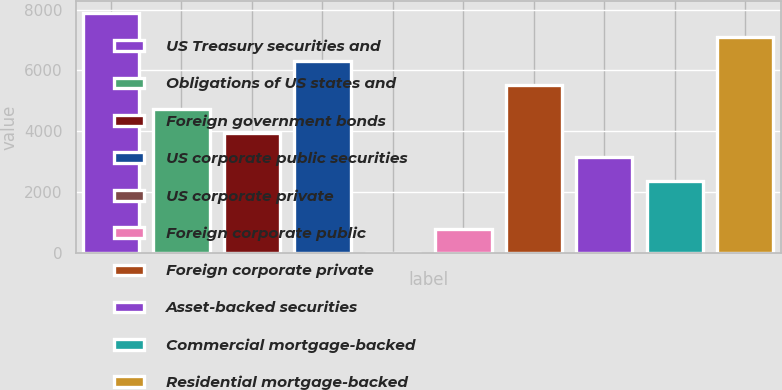Convert chart to OTSL. <chart><loc_0><loc_0><loc_500><loc_500><bar_chart><fcel>US Treasury securities and<fcel>Obligations of US states and<fcel>Foreign government bonds<fcel>US corporate public securities<fcel>US corporate private<fcel>Foreign corporate public<fcel>Foreign corporate private<fcel>Asset-backed securities<fcel>Commercial mortgage-backed<fcel>Residential mortgage-backed<nl><fcel>7881.96<fcel>4729.28<fcel>3941.11<fcel>6305.62<fcel>0.26<fcel>788.43<fcel>5517.45<fcel>3152.94<fcel>2364.77<fcel>7093.79<nl></chart> 